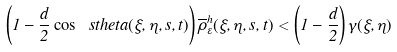Convert formula to latex. <formula><loc_0><loc_0><loc_500><loc_500>\left ( 1 - \frac { d } { 2 } \cos \ s t h e t a ( \xi , \eta , s , t ) \right ) \overline { \rho } _ { \varepsilon } ^ { h } ( \xi , \eta , s , t ) < \left ( 1 - \frac { d } { 2 } \right ) \gamma ( \xi , \eta )</formula> 